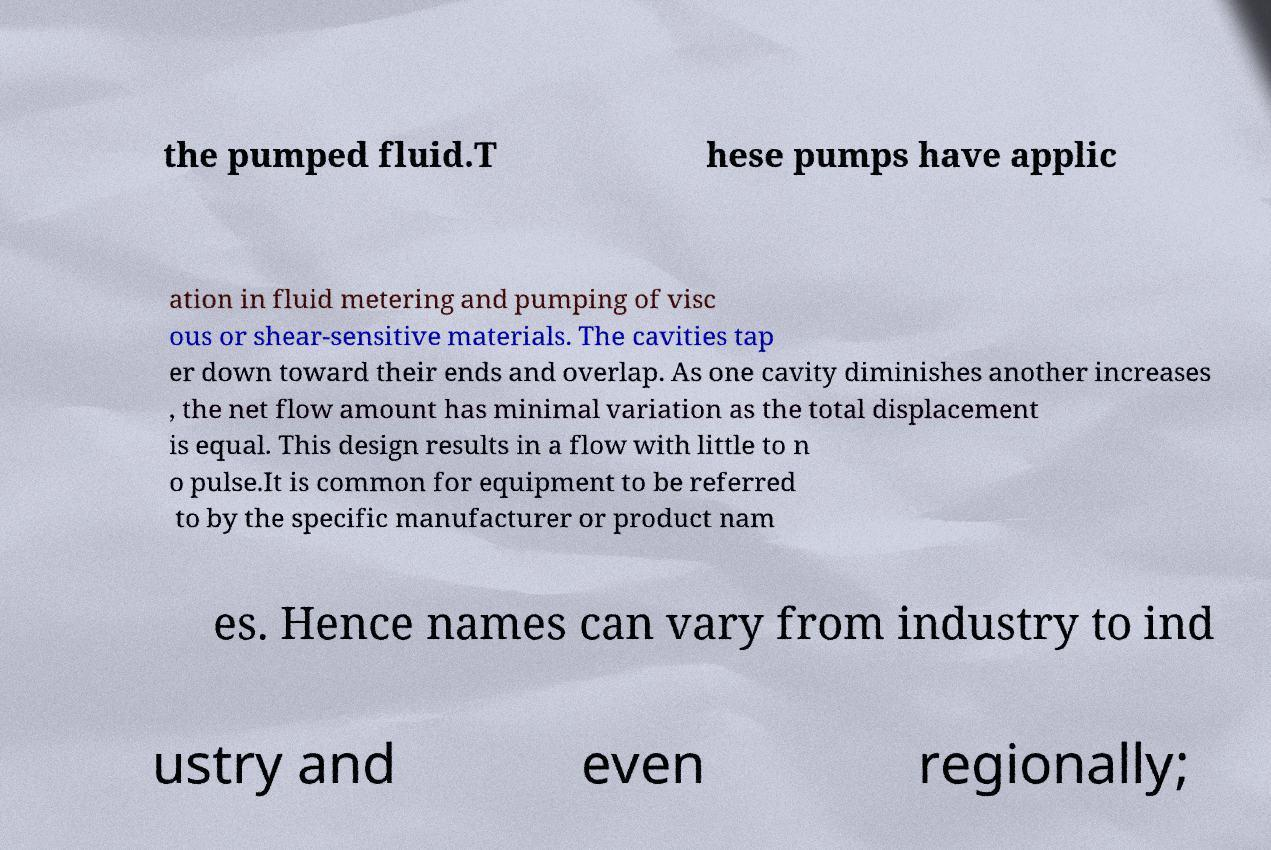Can you accurately transcribe the text from the provided image for me? the pumped fluid.T hese pumps have applic ation in fluid metering and pumping of visc ous or shear-sensitive materials. The cavities tap er down toward their ends and overlap. As one cavity diminishes another increases , the net flow amount has minimal variation as the total displacement is equal. This design results in a flow with little to n o pulse.It is common for equipment to be referred to by the specific manufacturer or product nam es. Hence names can vary from industry to ind ustry and even regionally; 